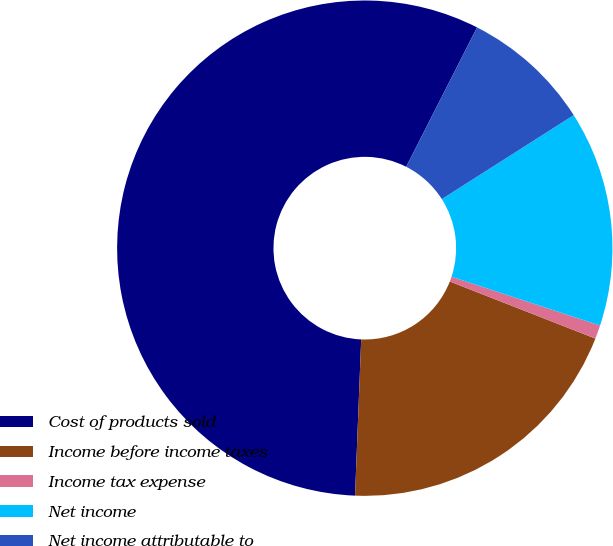Convert chart. <chart><loc_0><loc_0><loc_500><loc_500><pie_chart><fcel>Cost of products sold<fcel>Income before income taxes<fcel>Income tax expense<fcel>Net income<fcel>Net income attributable to<nl><fcel>56.86%<fcel>19.68%<fcel>0.89%<fcel>14.08%<fcel>8.49%<nl></chart> 